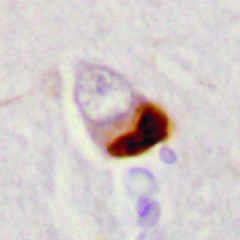what are cytoplasmic inclusions containing tdp43 seen in association with?
Answer the question using a single word or phrase. Loss of normal nuclear immunoreactivity 